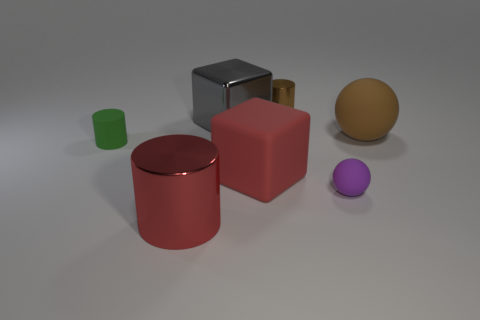Is the color of the tiny metal cylinder the same as the big rubber thing behind the small green cylinder?
Provide a short and direct response. Yes. Are there an equal number of red matte cubes right of the large brown rubber thing and tiny purple matte balls in front of the rubber cube?
Give a very brief answer. No. What is the ball that is in front of the green object made of?
Your answer should be very brief. Rubber. What number of objects are either tiny rubber objects that are to the right of the metal cube or small gray metal cylinders?
Make the answer very short. 1. What number of other objects are there of the same shape as the large gray metallic object?
Your answer should be very brief. 1. Is the shape of the large red object left of the rubber block the same as  the tiny purple matte object?
Keep it short and to the point. No. There is a tiny purple matte thing; are there any things behind it?
Provide a short and direct response. Yes. How many tiny things are either purple rubber things or matte objects?
Make the answer very short. 2. Are the purple sphere and the red cylinder made of the same material?
Offer a very short reply. No. The object that is the same color as the small metallic cylinder is what size?
Offer a very short reply. Large. 